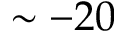<formula> <loc_0><loc_0><loc_500><loc_500>\sim - 2 0</formula> 